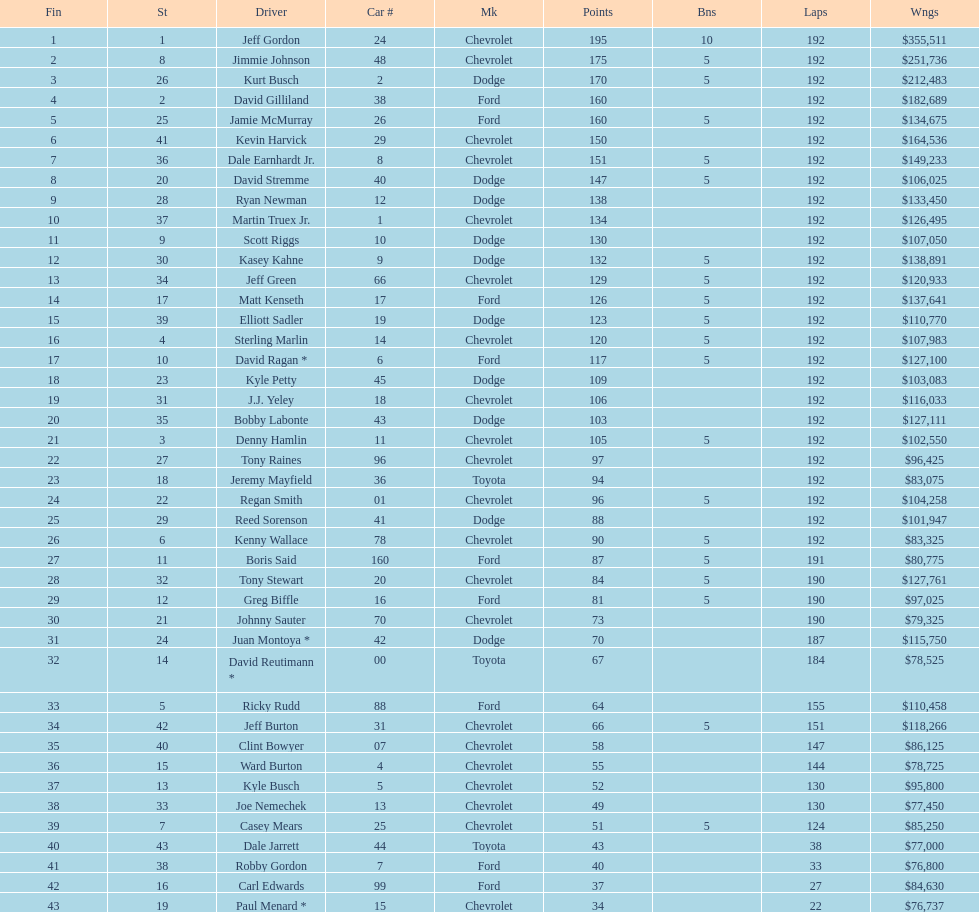Who got the most bonus points? Jeff Gordon. 